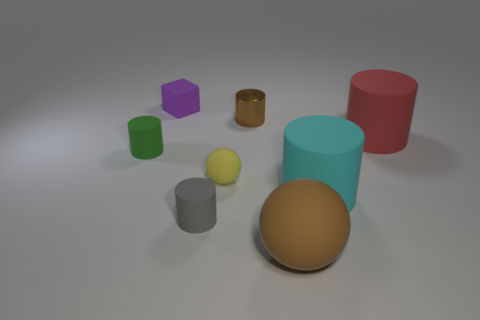Subtract 2 cylinders. How many cylinders are left? 3 Subtract all small gray rubber cylinders. How many cylinders are left? 4 Subtract all yellow cylinders. Subtract all green spheres. How many cylinders are left? 5 Add 1 big metal things. How many objects exist? 9 Subtract all blocks. How many objects are left? 7 Add 5 tiny brown cylinders. How many tiny brown cylinders exist? 6 Subtract 1 brown balls. How many objects are left? 7 Subtract all green matte things. Subtract all green rubber objects. How many objects are left? 6 Add 6 brown balls. How many brown balls are left? 7 